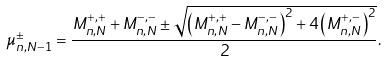<formula> <loc_0><loc_0><loc_500><loc_500>\mu _ { n , N - 1 } ^ { \pm } = \frac { M _ { n , N } ^ { + , + } + M _ { n , N } ^ { - , - } \pm \sqrt { \left ( M _ { n , N } ^ { + , + } - M _ { n , N } ^ { - , - } \right ) ^ { 2 } + 4 \left ( M _ { n , N } ^ { + , - } \right ) ^ { 2 } } } { 2 } .</formula> 